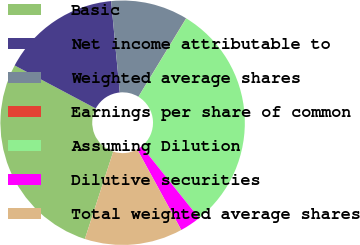Convert chart to OTSL. <chart><loc_0><loc_0><loc_500><loc_500><pie_chart><fcel>Basic<fcel>Net income attributable to<fcel>Weighted average shares<fcel>Earnings per share of common<fcel>Assuming Dilution<fcel>Dilutive securities<fcel>Total weighted average shares<nl><fcel>27.77%<fcel>15.74%<fcel>10.19%<fcel>0.02%<fcel>30.54%<fcel>2.79%<fcel>12.96%<nl></chart> 